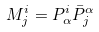Convert formula to latex. <formula><loc_0><loc_0><loc_500><loc_500>M ^ { i } _ { j } = P ^ { i } _ { \alpha } \bar { P } ^ { \alpha } _ { j }</formula> 